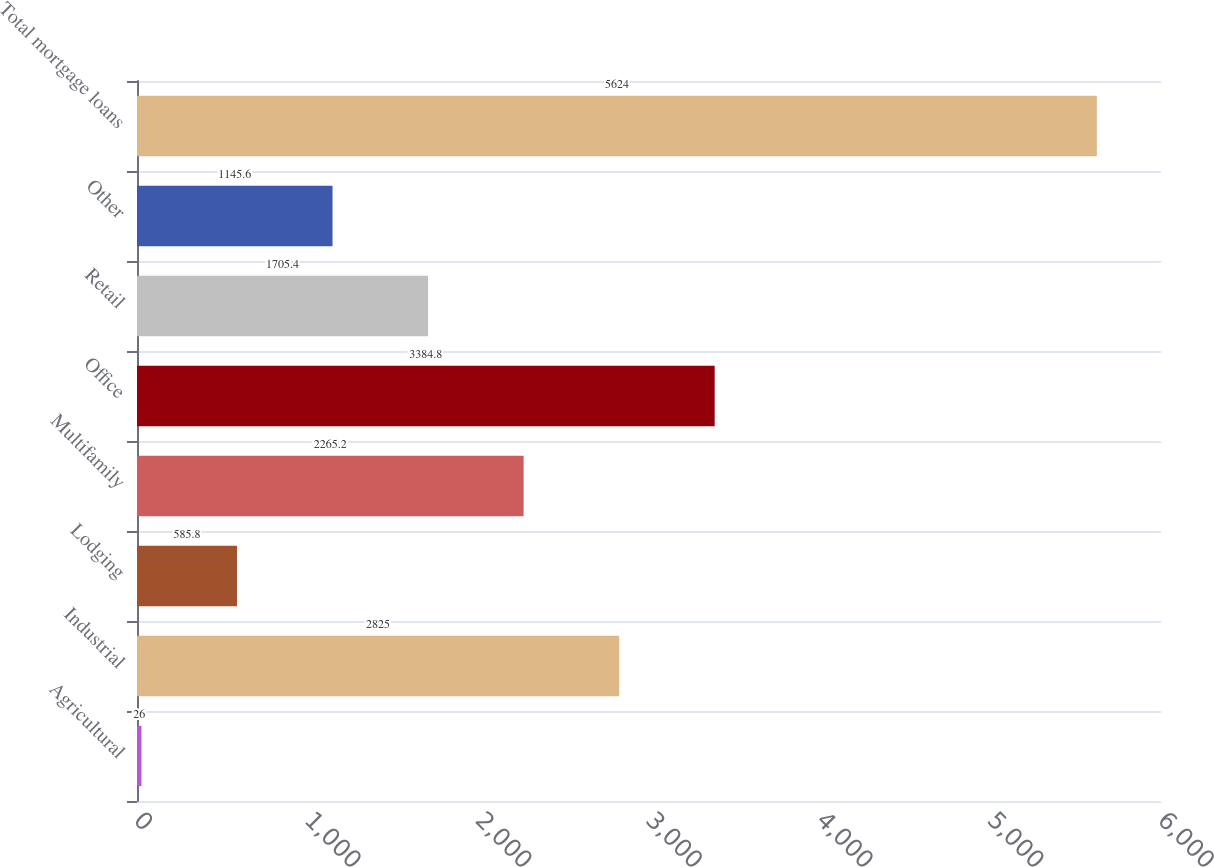Convert chart. <chart><loc_0><loc_0><loc_500><loc_500><bar_chart><fcel>Agricultural<fcel>Industrial<fcel>Lodging<fcel>Multifamily<fcel>Office<fcel>Retail<fcel>Other<fcel>Total mortgage loans<nl><fcel>26<fcel>2825<fcel>585.8<fcel>2265.2<fcel>3384.8<fcel>1705.4<fcel>1145.6<fcel>5624<nl></chart> 